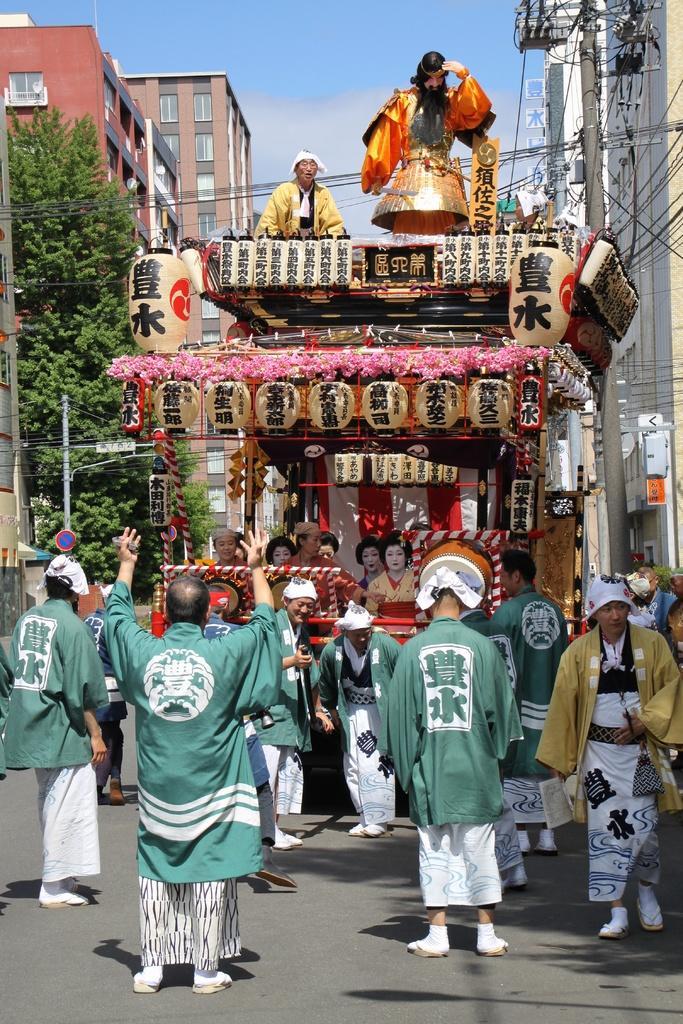How would you summarize this image in a sentence or two? In the picture I can see few persons wearing green dress are standing and there is a vehicle in front of them which has few persons sitting in it and there is another person sitting above it and there are trees in the left corner and there is a pole in the right corner and there are buildings in the background. 